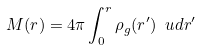Convert formula to latex. <formula><loc_0><loc_0><loc_500><loc_500>M ( r ) = 4 \pi \int _ { 0 } ^ { r } \rho _ { g } ( r ^ { \prime } ) \ u d r ^ { \prime }</formula> 